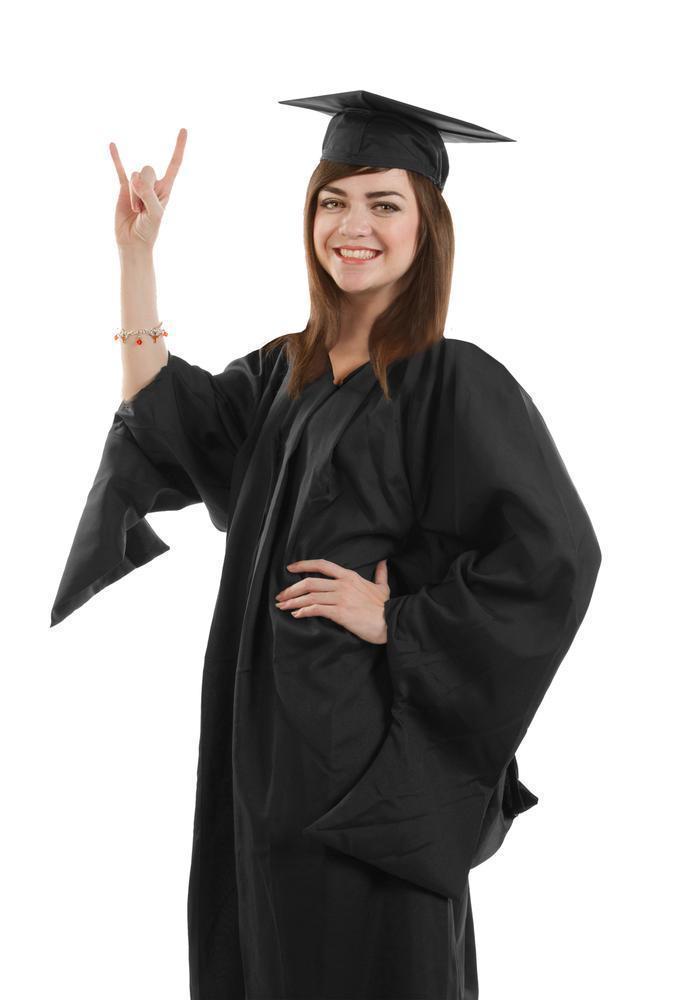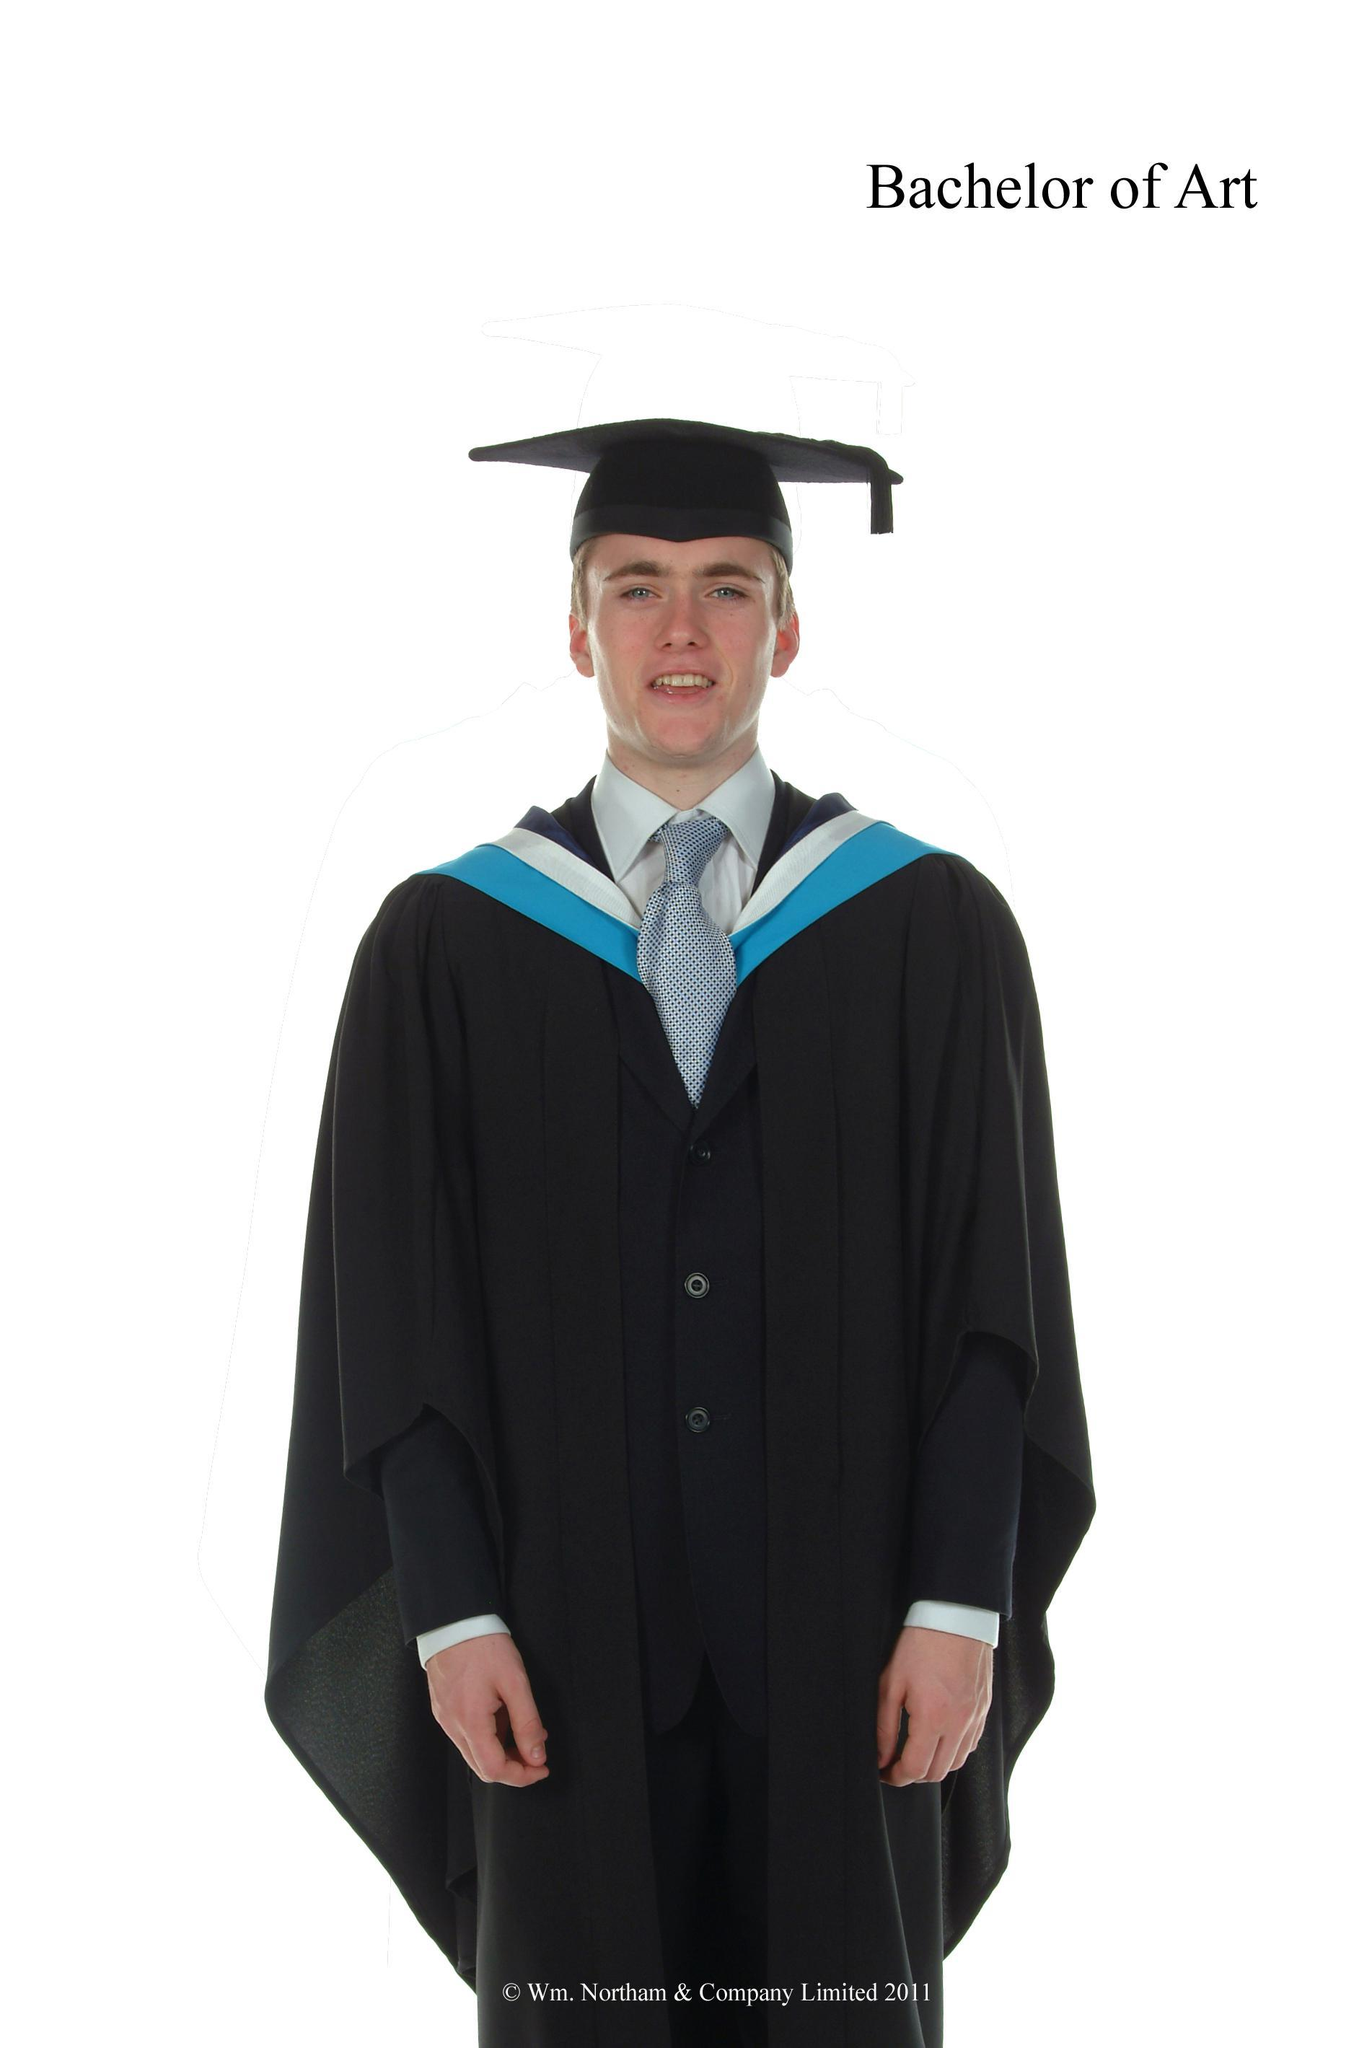The first image is the image on the left, the second image is the image on the right. Analyze the images presented: Is the assertion "An image features a forward-facing female in a black gown and black graduation cap." valid? Answer yes or no. Yes. 